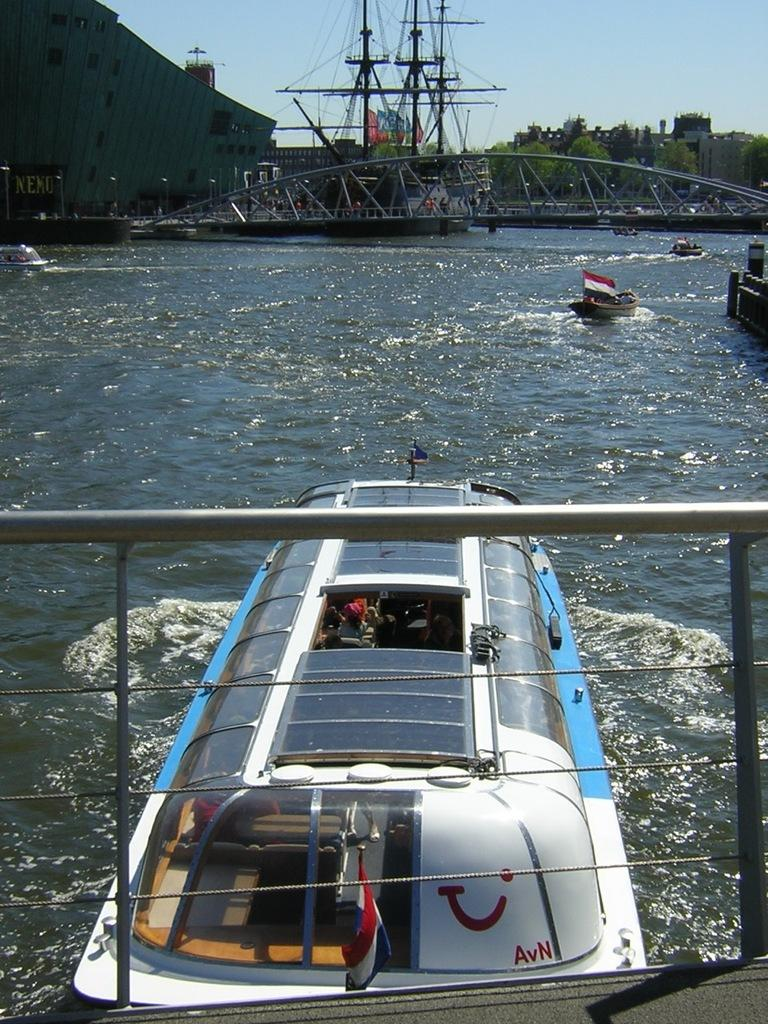What can be seen in the foreground of the image? In the foreground of the image, there is railing and a boat on the water. What else is present in the foreground of the image? There are no other objects or elements in the foreground besides the railing and boat. What can be seen in the background of the image? In the background of the image, there are boats, a ship, a bridge, trees, buildings, and the sky. Can you describe the water in the image? Yes, there is water visible in the image, with a boat on it in the foreground. What type of muscle is being flexed by the boat in the image? There are no muscles present in the image, as it features a boat on water. How many balloons are tied to the ship in the background of the image? There are no balloons present in the image; it features a ship, boats, a bridge, trees, buildings, and the sky in the background. 